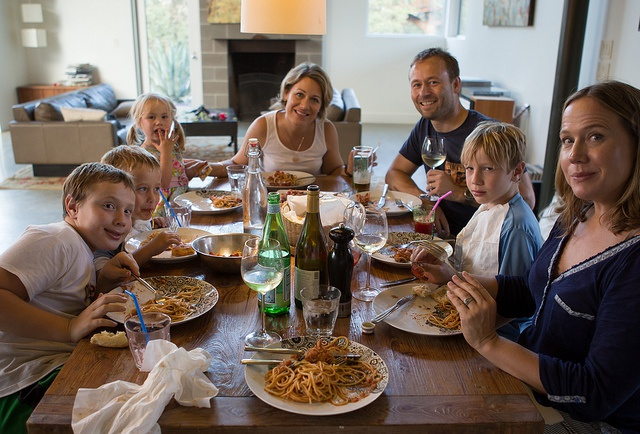Describe the objects in this image and their specific colors. I can see dining table in darkgray, maroon, black, and gray tones, people in darkgray, black, maroon, and brown tones, people in darkgray, maroon, gray, and black tones, people in darkgray, black, maroon, and brown tones, and people in darkgray, gray, black, and maroon tones in this image. 